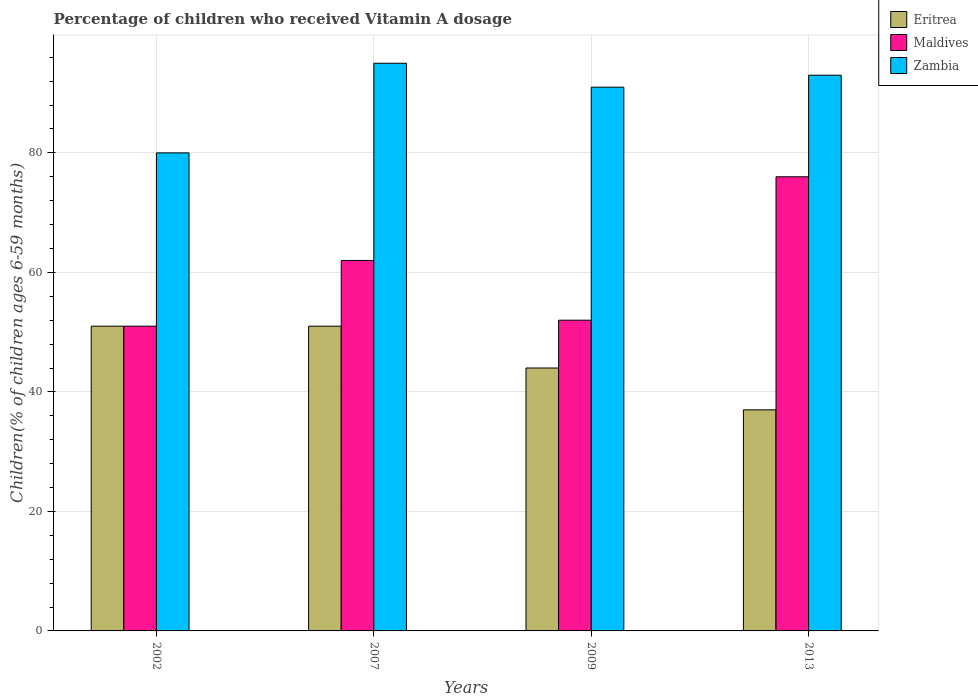Are the number of bars per tick equal to the number of legend labels?
Offer a very short reply. Yes. How many bars are there on the 3rd tick from the right?
Provide a short and direct response. 3. What is the percentage of children who received Vitamin A dosage in Maldives in 2007?
Ensure brevity in your answer.  62. Across all years, what is the minimum percentage of children who received Vitamin A dosage in Maldives?
Your response must be concise. 51. What is the total percentage of children who received Vitamin A dosage in Zambia in the graph?
Your response must be concise. 359. What is the difference between the percentage of children who received Vitamin A dosage in Maldives in 2007 and that in 2009?
Make the answer very short. 10. What is the difference between the percentage of children who received Vitamin A dosage in Zambia in 2002 and the percentage of children who received Vitamin A dosage in Maldives in 2013?
Keep it short and to the point. 4. What is the average percentage of children who received Vitamin A dosage in Zambia per year?
Provide a succinct answer. 89.75. In the year 2002, what is the difference between the percentage of children who received Vitamin A dosage in Zambia and percentage of children who received Vitamin A dosage in Eritrea?
Provide a succinct answer. 29. What is the ratio of the percentage of children who received Vitamin A dosage in Eritrea in 2007 to that in 2013?
Make the answer very short. 1.38. Is the difference between the percentage of children who received Vitamin A dosage in Zambia in 2002 and 2013 greater than the difference between the percentage of children who received Vitamin A dosage in Eritrea in 2002 and 2013?
Provide a short and direct response. No. What is the difference between the highest and the lowest percentage of children who received Vitamin A dosage in Zambia?
Make the answer very short. 15. Is the sum of the percentage of children who received Vitamin A dosage in Maldives in 2002 and 2013 greater than the maximum percentage of children who received Vitamin A dosage in Zambia across all years?
Keep it short and to the point. Yes. What does the 3rd bar from the left in 2007 represents?
Your answer should be compact. Zambia. What does the 1st bar from the right in 2013 represents?
Your response must be concise. Zambia. What is the difference between two consecutive major ticks on the Y-axis?
Your answer should be very brief. 20. Does the graph contain any zero values?
Give a very brief answer. No. Where does the legend appear in the graph?
Your answer should be compact. Top right. How are the legend labels stacked?
Give a very brief answer. Vertical. What is the title of the graph?
Provide a short and direct response. Percentage of children who received Vitamin A dosage. What is the label or title of the X-axis?
Offer a terse response. Years. What is the label or title of the Y-axis?
Provide a short and direct response. Children(% of children ages 6-59 months). What is the Children(% of children ages 6-59 months) in Maldives in 2007?
Your answer should be very brief. 62. What is the Children(% of children ages 6-59 months) of Zambia in 2007?
Make the answer very short. 95. What is the Children(% of children ages 6-59 months) of Eritrea in 2009?
Offer a very short reply. 44. What is the Children(% of children ages 6-59 months) in Maldives in 2009?
Your answer should be very brief. 52. What is the Children(% of children ages 6-59 months) in Zambia in 2009?
Your answer should be very brief. 91. What is the Children(% of children ages 6-59 months) in Eritrea in 2013?
Offer a terse response. 37. What is the Children(% of children ages 6-59 months) of Zambia in 2013?
Offer a very short reply. 93. Across all years, what is the maximum Children(% of children ages 6-59 months) in Zambia?
Provide a succinct answer. 95. Across all years, what is the minimum Children(% of children ages 6-59 months) of Eritrea?
Keep it short and to the point. 37. What is the total Children(% of children ages 6-59 months) of Eritrea in the graph?
Ensure brevity in your answer.  183. What is the total Children(% of children ages 6-59 months) of Maldives in the graph?
Offer a terse response. 241. What is the total Children(% of children ages 6-59 months) in Zambia in the graph?
Your response must be concise. 359. What is the difference between the Children(% of children ages 6-59 months) of Eritrea in 2002 and that in 2007?
Your response must be concise. 0. What is the difference between the Children(% of children ages 6-59 months) of Zambia in 2002 and that in 2007?
Your answer should be very brief. -15. What is the difference between the Children(% of children ages 6-59 months) of Eritrea in 2002 and that in 2009?
Make the answer very short. 7. What is the difference between the Children(% of children ages 6-59 months) of Zambia in 2002 and that in 2009?
Your answer should be compact. -11. What is the difference between the Children(% of children ages 6-59 months) in Eritrea in 2002 and that in 2013?
Provide a succinct answer. 14. What is the difference between the Children(% of children ages 6-59 months) of Maldives in 2002 and that in 2013?
Give a very brief answer. -25. What is the difference between the Children(% of children ages 6-59 months) in Zambia in 2002 and that in 2013?
Provide a succinct answer. -13. What is the difference between the Children(% of children ages 6-59 months) of Maldives in 2007 and that in 2009?
Your answer should be very brief. 10. What is the difference between the Children(% of children ages 6-59 months) in Eritrea in 2009 and that in 2013?
Give a very brief answer. 7. What is the difference between the Children(% of children ages 6-59 months) of Maldives in 2009 and that in 2013?
Offer a terse response. -24. What is the difference between the Children(% of children ages 6-59 months) of Eritrea in 2002 and the Children(% of children ages 6-59 months) of Zambia in 2007?
Your answer should be compact. -44. What is the difference between the Children(% of children ages 6-59 months) of Maldives in 2002 and the Children(% of children ages 6-59 months) of Zambia in 2007?
Provide a succinct answer. -44. What is the difference between the Children(% of children ages 6-59 months) of Eritrea in 2002 and the Children(% of children ages 6-59 months) of Zambia in 2009?
Keep it short and to the point. -40. What is the difference between the Children(% of children ages 6-59 months) of Eritrea in 2002 and the Children(% of children ages 6-59 months) of Maldives in 2013?
Offer a very short reply. -25. What is the difference between the Children(% of children ages 6-59 months) in Eritrea in 2002 and the Children(% of children ages 6-59 months) in Zambia in 2013?
Offer a terse response. -42. What is the difference between the Children(% of children ages 6-59 months) in Maldives in 2002 and the Children(% of children ages 6-59 months) in Zambia in 2013?
Make the answer very short. -42. What is the difference between the Children(% of children ages 6-59 months) of Eritrea in 2007 and the Children(% of children ages 6-59 months) of Maldives in 2009?
Offer a terse response. -1. What is the difference between the Children(% of children ages 6-59 months) in Eritrea in 2007 and the Children(% of children ages 6-59 months) in Zambia in 2009?
Give a very brief answer. -40. What is the difference between the Children(% of children ages 6-59 months) in Maldives in 2007 and the Children(% of children ages 6-59 months) in Zambia in 2009?
Ensure brevity in your answer.  -29. What is the difference between the Children(% of children ages 6-59 months) in Eritrea in 2007 and the Children(% of children ages 6-59 months) in Maldives in 2013?
Offer a terse response. -25. What is the difference between the Children(% of children ages 6-59 months) in Eritrea in 2007 and the Children(% of children ages 6-59 months) in Zambia in 2013?
Give a very brief answer. -42. What is the difference between the Children(% of children ages 6-59 months) in Maldives in 2007 and the Children(% of children ages 6-59 months) in Zambia in 2013?
Provide a short and direct response. -31. What is the difference between the Children(% of children ages 6-59 months) of Eritrea in 2009 and the Children(% of children ages 6-59 months) of Maldives in 2013?
Keep it short and to the point. -32. What is the difference between the Children(% of children ages 6-59 months) in Eritrea in 2009 and the Children(% of children ages 6-59 months) in Zambia in 2013?
Ensure brevity in your answer.  -49. What is the difference between the Children(% of children ages 6-59 months) in Maldives in 2009 and the Children(% of children ages 6-59 months) in Zambia in 2013?
Offer a very short reply. -41. What is the average Children(% of children ages 6-59 months) in Eritrea per year?
Your response must be concise. 45.75. What is the average Children(% of children ages 6-59 months) in Maldives per year?
Your answer should be compact. 60.25. What is the average Children(% of children ages 6-59 months) in Zambia per year?
Offer a terse response. 89.75. In the year 2002, what is the difference between the Children(% of children ages 6-59 months) in Eritrea and Children(% of children ages 6-59 months) in Maldives?
Offer a very short reply. 0. In the year 2007, what is the difference between the Children(% of children ages 6-59 months) in Eritrea and Children(% of children ages 6-59 months) in Maldives?
Give a very brief answer. -11. In the year 2007, what is the difference between the Children(% of children ages 6-59 months) in Eritrea and Children(% of children ages 6-59 months) in Zambia?
Your answer should be very brief. -44. In the year 2007, what is the difference between the Children(% of children ages 6-59 months) in Maldives and Children(% of children ages 6-59 months) in Zambia?
Offer a terse response. -33. In the year 2009, what is the difference between the Children(% of children ages 6-59 months) in Eritrea and Children(% of children ages 6-59 months) in Zambia?
Provide a short and direct response. -47. In the year 2009, what is the difference between the Children(% of children ages 6-59 months) of Maldives and Children(% of children ages 6-59 months) of Zambia?
Offer a terse response. -39. In the year 2013, what is the difference between the Children(% of children ages 6-59 months) of Eritrea and Children(% of children ages 6-59 months) of Maldives?
Your answer should be compact. -39. In the year 2013, what is the difference between the Children(% of children ages 6-59 months) in Eritrea and Children(% of children ages 6-59 months) in Zambia?
Offer a terse response. -56. In the year 2013, what is the difference between the Children(% of children ages 6-59 months) in Maldives and Children(% of children ages 6-59 months) in Zambia?
Keep it short and to the point. -17. What is the ratio of the Children(% of children ages 6-59 months) of Eritrea in 2002 to that in 2007?
Offer a very short reply. 1. What is the ratio of the Children(% of children ages 6-59 months) of Maldives in 2002 to that in 2007?
Provide a succinct answer. 0.82. What is the ratio of the Children(% of children ages 6-59 months) of Zambia in 2002 to that in 2007?
Give a very brief answer. 0.84. What is the ratio of the Children(% of children ages 6-59 months) in Eritrea in 2002 to that in 2009?
Provide a short and direct response. 1.16. What is the ratio of the Children(% of children ages 6-59 months) of Maldives in 2002 to that in 2009?
Give a very brief answer. 0.98. What is the ratio of the Children(% of children ages 6-59 months) in Zambia in 2002 to that in 2009?
Your answer should be very brief. 0.88. What is the ratio of the Children(% of children ages 6-59 months) of Eritrea in 2002 to that in 2013?
Your response must be concise. 1.38. What is the ratio of the Children(% of children ages 6-59 months) of Maldives in 2002 to that in 2013?
Make the answer very short. 0.67. What is the ratio of the Children(% of children ages 6-59 months) of Zambia in 2002 to that in 2013?
Provide a succinct answer. 0.86. What is the ratio of the Children(% of children ages 6-59 months) in Eritrea in 2007 to that in 2009?
Your response must be concise. 1.16. What is the ratio of the Children(% of children ages 6-59 months) of Maldives in 2007 to that in 2009?
Make the answer very short. 1.19. What is the ratio of the Children(% of children ages 6-59 months) of Zambia in 2007 to that in 2009?
Your response must be concise. 1.04. What is the ratio of the Children(% of children ages 6-59 months) in Eritrea in 2007 to that in 2013?
Offer a very short reply. 1.38. What is the ratio of the Children(% of children ages 6-59 months) in Maldives in 2007 to that in 2013?
Make the answer very short. 0.82. What is the ratio of the Children(% of children ages 6-59 months) of Zambia in 2007 to that in 2013?
Your answer should be very brief. 1.02. What is the ratio of the Children(% of children ages 6-59 months) in Eritrea in 2009 to that in 2013?
Your answer should be very brief. 1.19. What is the ratio of the Children(% of children ages 6-59 months) of Maldives in 2009 to that in 2013?
Your answer should be very brief. 0.68. What is the ratio of the Children(% of children ages 6-59 months) in Zambia in 2009 to that in 2013?
Provide a succinct answer. 0.98. What is the difference between the highest and the second highest Children(% of children ages 6-59 months) of Maldives?
Your answer should be compact. 14. What is the difference between the highest and the second highest Children(% of children ages 6-59 months) in Zambia?
Offer a very short reply. 2. What is the difference between the highest and the lowest Children(% of children ages 6-59 months) in Eritrea?
Offer a very short reply. 14. 